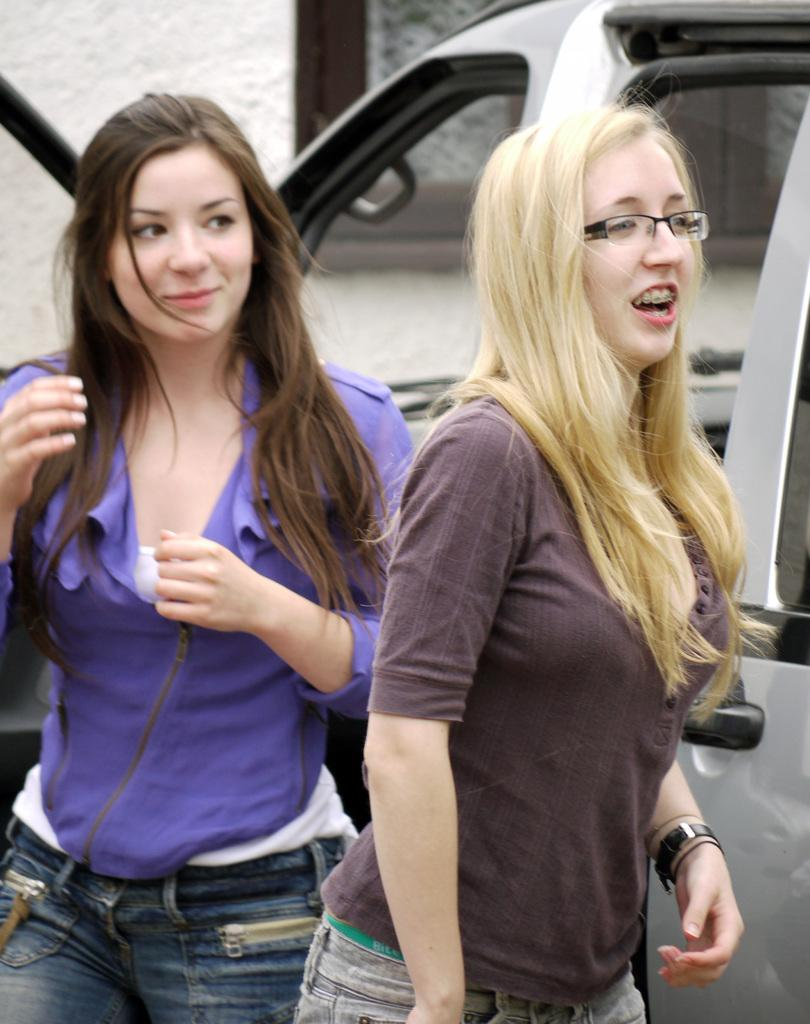What can be seen in the image? There are women standing in the image. Where are the women standing? The women are standing on the floor. What can be seen in the background of the image? There is a car, a wall, and a window in the background of the image. Are the women crying in the image? There is no indication in the image that the women are crying. What type of stocking is the woman on the left wearing? There is no information about the women's clothing, including stockings, in the image. 